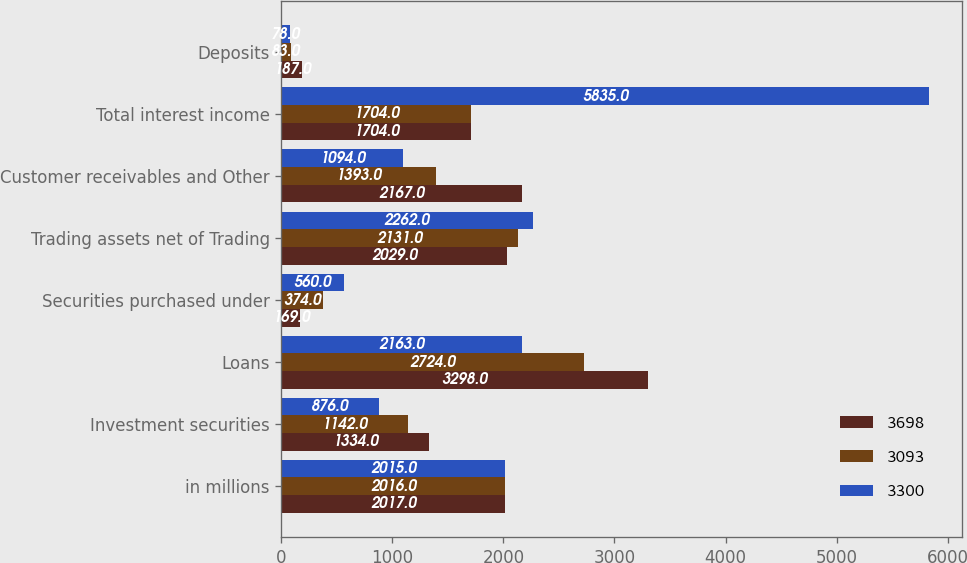Convert chart to OTSL. <chart><loc_0><loc_0><loc_500><loc_500><stacked_bar_chart><ecel><fcel>in millions<fcel>Investment securities<fcel>Loans<fcel>Securities purchased under<fcel>Trading assets net of Trading<fcel>Customer receivables and Other<fcel>Total interest income<fcel>Deposits<nl><fcel>3698<fcel>2017<fcel>1334<fcel>3298<fcel>169<fcel>2029<fcel>2167<fcel>1704<fcel>187<nl><fcel>3093<fcel>2016<fcel>1142<fcel>2724<fcel>374<fcel>2131<fcel>1393<fcel>1704<fcel>83<nl><fcel>3300<fcel>2015<fcel>876<fcel>2163<fcel>560<fcel>2262<fcel>1094<fcel>5835<fcel>78<nl></chart> 